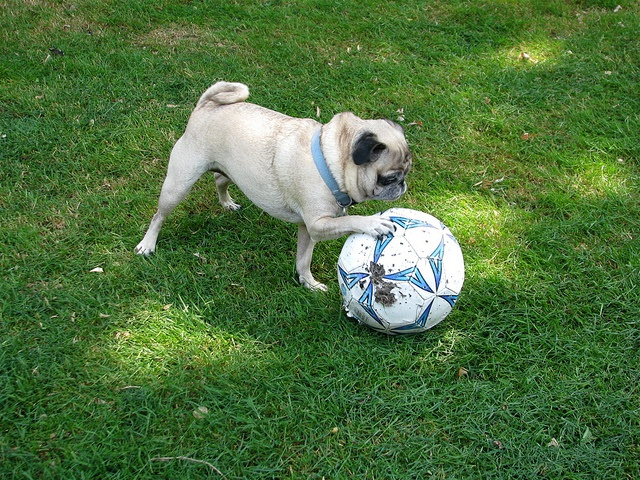Describe the objects in this image and their specific colors. I can see dog in darkgreen, lightgray, darkgray, and gray tones and sports ball in darkgreen, white, darkgray, gray, and lightblue tones in this image. 